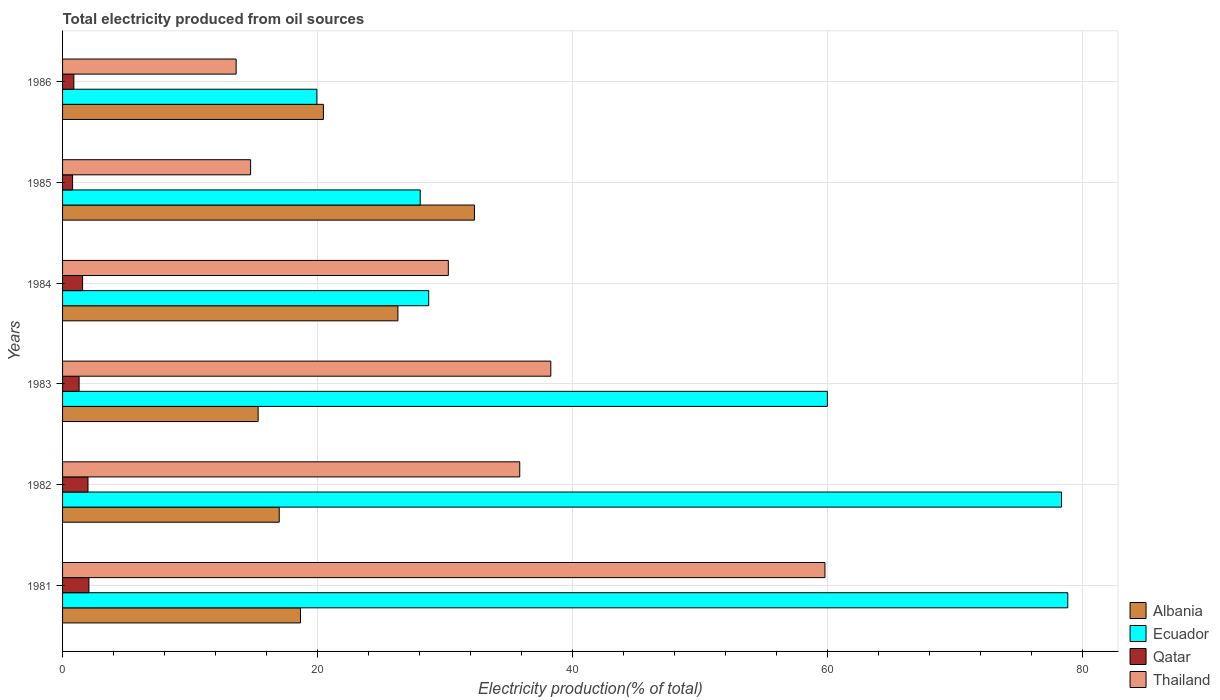How many different coloured bars are there?
Offer a terse response. 4. How many groups of bars are there?
Make the answer very short. 6. Are the number of bars per tick equal to the number of legend labels?
Your response must be concise. Yes. Are the number of bars on each tick of the Y-axis equal?
Provide a succinct answer. Yes. How many bars are there on the 6th tick from the bottom?
Offer a terse response. 4. In how many cases, is the number of bars for a given year not equal to the number of legend labels?
Give a very brief answer. 0. What is the total electricity produced in Albania in 1981?
Your answer should be very brief. 18.67. Across all years, what is the maximum total electricity produced in Ecuador?
Your answer should be very brief. 78.87. Across all years, what is the minimum total electricity produced in Thailand?
Your response must be concise. 13.62. What is the total total electricity produced in Thailand in the graph?
Ensure brevity in your answer.  192.63. What is the difference between the total electricity produced in Thailand in 1981 and that in 1984?
Provide a succinct answer. 29.55. What is the difference between the total electricity produced in Qatar in 1981 and the total electricity produced in Albania in 1984?
Make the answer very short. -24.24. What is the average total electricity produced in Thailand per year?
Ensure brevity in your answer.  32.1. In the year 1982, what is the difference between the total electricity produced in Thailand and total electricity produced in Qatar?
Your answer should be compact. 33.88. What is the ratio of the total electricity produced in Ecuador in 1981 to that in 1984?
Provide a short and direct response. 2.75. What is the difference between the highest and the second highest total electricity produced in Ecuador?
Make the answer very short. 0.49. What is the difference between the highest and the lowest total electricity produced in Ecuador?
Offer a very short reply. 58.91. Is it the case that in every year, the sum of the total electricity produced in Albania and total electricity produced in Ecuador is greater than the sum of total electricity produced in Qatar and total electricity produced in Thailand?
Give a very brief answer. Yes. What does the 2nd bar from the top in 1984 represents?
Provide a succinct answer. Qatar. What does the 3rd bar from the bottom in 1986 represents?
Your answer should be compact. Qatar. How many bars are there?
Keep it short and to the point. 24. Are all the bars in the graph horizontal?
Make the answer very short. Yes. What is the difference between two consecutive major ticks on the X-axis?
Keep it short and to the point. 20. Does the graph contain grids?
Keep it short and to the point. Yes. How many legend labels are there?
Offer a very short reply. 4. What is the title of the graph?
Keep it short and to the point. Total electricity produced from oil sources. Does "Algeria" appear as one of the legend labels in the graph?
Give a very brief answer. No. What is the Electricity production(% of total) in Albania in 1981?
Your answer should be very brief. 18.67. What is the Electricity production(% of total) of Ecuador in 1981?
Your answer should be very brief. 78.87. What is the Electricity production(% of total) of Qatar in 1981?
Provide a short and direct response. 2.07. What is the Electricity production(% of total) of Thailand in 1981?
Offer a terse response. 59.82. What is the Electricity production(% of total) of Albania in 1982?
Provide a succinct answer. 17. What is the Electricity production(% of total) in Ecuador in 1982?
Provide a succinct answer. 78.38. What is the Electricity production(% of total) in Qatar in 1982?
Keep it short and to the point. 1.99. What is the Electricity production(% of total) of Thailand in 1982?
Make the answer very short. 35.87. What is the Electricity production(% of total) of Albania in 1983?
Your answer should be compact. 15.34. What is the Electricity production(% of total) of Ecuador in 1983?
Provide a short and direct response. 60. What is the Electricity production(% of total) of Qatar in 1983?
Offer a very short reply. 1.3. What is the Electricity production(% of total) of Thailand in 1983?
Ensure brevity in your answer.  38.31. What is the Electricity production(% of total) of Albania in 1984?
Give a very brief answer. 26.31. What is the Electricity production(% of total) in Ecuador in 1984?
Keep it short and to the point. 28.73. What is the Electricity production(% of total) of Qatar in 1984?
Your answer should be compact. 1.57. What is the Electricity production(% of total) of Thailand in 1984?
Offer a terse response. 30.27. What is the Electricity production(% of total) of Albania in 1985?
Provide a succinct answer. 32.32. What is the Electricity production(% of total) of Ecuador in 1985?
Offer a very short reply. 28.06. What is the Electricity production(% of total) in Qatar in 1985?
Make the answer very short. 0.79. What is the Electricity production(% of total) in Thailand in 1985?
Your answer should be very brief. 14.75. What is the Electricity production(% of total) in Albania in 1986?
Offer a terse response. 20.47. What is the Electricity production(% of total) of Ecuador in 1986?
Your answer should be compact. 19.95. What is the Electricity production(% of total) in Qatar in 1986?
Offer a terse response. 0.89. What is the Electricity production(% of total) of Thailand in 1986?
Your response must be concise. 13.62. Across all years, what is the maximum Electricity production(% of total) in Albania?
Your response must be concise. 32.32. Across all years, what is the maximum Electricity production(% of total) in Ecuador?
Provide a short and direct response. 78.87. Across all years, what is the maximum Electricity production(% of total) in Qatar?
Your answer should be compact. 2.07. Across all years, what is the maximum Electricity production(% of total) of Thailand?
Your answer should be very brief. 59.82. Across all years, what is the minimum Electricity production(% of total) in Albania?
Ensure brevity in your answer.  15.34. Across all years, what is the minimum Electricity production(% of total) of Ecuador?
Give a very brief answer. 19.95. Across all years, what is the minimum Electricity production(% of total) of Qatar?
Provide a short and direct response. 0.79. Across all years, what is the minimum Electricity production(% of total) in Thailand?
Provide a succinct answer. 13.62. What is the total Electricity production(% of total) in Albania in the graph?
Offer a very short reply. 130.1. What is the total Electricity production(% of total) of Ecuador in the graph?
Provide a succinct answer. 293.99. What is the total Electricity production(% of total) in Qatar in the graph?
Your response must be concise. 8.6. What is the total Electricity production(% of total) in Thailand in the graph?
Provide a succinct answer. 192.63. What is the difference between the Electricity production(% of total) in Albania in 1981 and that in 1982?
Keep it short and to the point. 1.67. What is the difference between the Electricity production(% of total) of Ecuador in 1981 and that in 1982?
Make the answer very short. 0.49. What is the difference between the Electricity production(% of total) of Qatar in 1981 and that in 1982?
Ensure brevity in your answer.  0.07. What is the difference between the Electricity production(% of total) of Thailand in 1981 and that in 1982?
Provide a succinct answer. 23.95. What is the difference between the Electricity production(% of total) of Albania in 1981 and that in 1983?
Offer a terse response. 3.32. What is the difference between the Electricity production(% of total) of Ecuador in 1981 and that in 1983?
Ensure brevity in your answer.  18.86. What is the difference between the Electricity production(% of total) in Qatar in 1981 and that in 1983?
Keep it short and to the point. 0.77. What is the difference between the Electricity production(% of total) in Thailand in 1981 and that in 1983?
Provide a short and direct response. 21.51. What is the difference between the Electricity production(% of total) in Albania in 1981 and that in 1984?
Your answer should be compact. -7.64. What is the difference between the Electricity production(% of total) of Ecuador in 1981 and that in 1984?
Provide a succinct answer. 50.14. What is the difference between the Electricity production(% of total) of Qatar in 1981 and that in 1984?
Provide a short and direct response. 0.5. What is the difference between the Electricity production(% of total) of Thailand in 1981 and that in 1984?
Make the answer very short. 29.55. What is the difference between the Electricity production(% of total) in Albania in 1981 and that in 1985?
Provide a succinct answer. -13.65. What is the difference between the Electricity production(% of total) in Ecuador in 1981 and that in 1985?
Keep it short and to the point. 50.81. What is the difference between the Electricity production(% of total) in Qatar in 1981 and that in 1985?
Provide a short and direct response. 1.28. What is the difference between the Electricity production(% of total) in Thailand in 1981 and that in 1985?
Your answer should be very brief. 45.06. What is the difference between the Electricity production(% of total) of Albania in 1981 and that in 1986?
Provide a short and direct response. -1.8. What is the difference between the Electricity production(% of total) of Ecuador in 1981 and that in 1986?
Offer a very short reply. 58.91. What is the difference between the Electricity production(% of total) in Qatar in 1981 and that in 1986?
Your answer should be very brief. 1.18. What is the difference between the Electricity production(% of total) of Thailand in 1981 and that in 1986?
Provide a short and direct response. 46.2. What is the difference between the Electricity production(% of total) in Albania in 1982 and that in 1983?
Keep it short and to the point. 1.65. What is the difference between the Electricity production(% of total) of Ecuador in 1982 and that in 1983?
Your response must be concise. 18.37. What is the difference between the Electricity production(% of total) of Qatar in 1982 and that in 1983?
Ensure brevity in your answer.  0.7. What is the difference between the Electricity production(% of total) in Thailand in 1982 and that in 1983?
Make the answer very short. -2.44. What is the difference between the Electricity production(% of total) of Albania in 1982 and that in 1984?
Offer a very short reply. -9.31. What is the difference between the Electricity production(% of total) of Ecuador in 1982 and that in 1984?
Provide a succinct answer. 49.65. What is the difference between the Electricity production(% of total) in Qatar in 1982 and that in 1984?
Make the answer very short. 0.42. What is the difference between the Electricity production(% of total) of Thailand in 1982 and that in 1984?
Ensure brevity in your answer.  5.6. What is the difference between the Electricity production(% of total) of Albania in 1982 and that in 1985?
Make the answer very short. -15.32. What is the difference between the Electricity production(% of total) of Ecuador in 1982 and that in 1985?
Make the answer very short. 50.32. What is the difference between the Electricity production(% of total) of Qatar in 1982 and that in 1985?
Provide a short and direct response. 1.21. What is the difference between the Electricity production(% of total) in Thailand in 1982 and that in 1985?
Offer a very short reply. 21.12. What is the difference between the Electricity production(% of total) of Albania in 1982 and that in 1986?
Offer a terse response. -3.47. What is the difference between the Electricity production(% of total) of Ecuador in 1982 and that in 1986?
Provide a short and direct response. 58.42. What is the difference between the Electricity production(% of total) of Qatar in 1982 and that in 1986?
Provide a succinct answer. 1.11. What is the difference between the Electricity production(% of total) of Thailand in 1982 and that in 1986?
Keep it short and to the point. 22.25. What is the difference between the Electricity production(% of total) of Albania in 1983 and that in 1984?
Offer a very short reply. -10.97. What is the difference between the Electricity production(% of total) in Ecuador in 1983 and that in 1984?
Ensure brevity in your answer.  31.28. What is the difference between the Electricity production(% of total) of Qatar in 1983 and that in 1984?
Ensure brevity in your answer.  -0.27. What is the difference between the Electricity production(% of total) of Thailand in 1983 and that in 1984?
Make the answer very short. 8.04. What is the difference between the Electricity production(% of total) of Albania in 1983 and that in 1985?
Ensure brevity in your answer.  -16.97. What is the difference between the Electricity production(% of total) in Ecuador in 1983 and that in 1985?
Keep it short and to the point. 31.94. What is the difference between the Electricity production(% of total) of Qatar in 1983 and that in 1985?
Your response must be concise. 0.51. What is the difference between the Electricity production(% of total) of Thailand in 1983 and that in 1985?
Offer a very short reply. 23.55. What is the difference between the Electricity production(% of total) of Albania in 1983 and that in 1986?
Offer a terse response. -5.12. What is the difference between the Electricity production(% of total) of Ecuador in 1983 and that in 1986?
Make the answer very short. 40.05. What is the difference between the Electricity production(% of total) in Qatar in 1983 and that in 1986?
Make the answer very short. 0.41. What is the difference between the Electricity production(% of total) in Thailand in 1983 and that in 1986?
Provide a short and direct response. 24.69. What is the difference between the Electricity production(% of total) in Albania in 1984 and that in 1985?
Your answer should be compact. -6. What is the difference between the Electricity production(% of total) in Ecuador in 1984 and that in 1985?
Your answer should be very brief. 0.67. What is the difference between the Electricity production(% of total) in Qatar in 1984 and that in 1985?
Offer a very short reply. 0.79. What is the difference between the Electricity production(% of total) of Thailand in 1984 and that in 1985?
Your answer should be very brief. 15.51. What is the difference between the Electricity production(% of total) in Albania in 1984 and that in 1986?
Ensure brevity in your answer.  5.85. What is the difference between the Electricity production(% of total) of Ecuador in 1984 and that in 1986?
Provide a succinct answer. 8.77. What is the difference between the Electricity production(% of total) of Qatar in 1984 and that in 1986?
Your answer should be very brief. 0.69. What is the difference between the Electricity production(% of total) of Thailand in 1984 and that in 1986?
Keep it short and to the point. 16.65. What is the difference between the Electricity production(% of total) in Albania in 1985 and that in 1986?
Your response must be concise. 11.85. What is the difference between the Electricity production(% of total) in Ecuador in 1985 and that in 1986?
Provide a succinct answer. 8.11. What is the difference between the Electricity production(% of total) in Qatar in 1985 and that in 1986?
Give a very brief answer. -0.1. What is the difference between the Electricity production(% of total) in Thailand in 1985 and that in 1986?
Offer a terse response. 1.13. What is the difference between the Electricity production(% of total) in Albania in 1981 and the Electricity production(% of total) in Ecuador in 1982?
Provide a short and direct response. -59.71. What is the difference between the Electricity production(% of total) in Albania in 1981 and the Electricity production(% of total) in Qatar in 1982?
Your response must be concise. 16.67. What is the difference between the Electricity production(% of total) of Albania in 1981 and the Electricity production(% of total) of Thailand in 1982?
Keep it short and to the point. -17.2. What is the difference between the Electricity production(% of total) of Ecuador in 1981 and the Electricity production(% of total) of Qatar in 1982?
Keep it short and to the point. 76.87. What is the difference between the Electricity production(% of total) of Ecuador in 1981 and the Electricity production(% of total) of Thailand in 1982?
Give a very brief answer. 43. What is the difference between the Electricity production(% of total) in Qatar in 1981 and the Electricity production(% of total) in Thailand in 1982?
Your response must be concise. -33.8. What is the difference between the Electricity production(% of total) of Albania in 1981 and the Electricity production(% of total) of Ecuador in 1983?
Offer a very short reply. -41.34. What is the difference between the Electricity production(% of total) of Albania in 1981 and the Electricity production(% of total) of Qatar in 1983?
Offer a terse response. 17.37. What is the difference between the Electricity production(% of total) in Albania in 1981 and the Electricity production(% of total) in Thailand in 1983?
Provide a succinct answer. -19.64. What is the difference between the Electricity production(% of total) of Ecuador in 1981 and the Electricity production(% of total) of Qatar in 1983?
Give a very brief answer. 77.57. What is the difference between the Electricity production(% of total) of Ecuador in 1981 and the Electricity production(% of total) of Thailand in 1983?
Provide a short and direct response. 40.56. What is the difference between the Electricity production(% of total) in Qatar in 1981 and the Electricity production(% of total) in Thailand in 1983?
Your answer should be compact. -36.24. What is the difference between the Electricity production(% of total) of Albania in 1981 and the Electricity production(% of total) of Ecuador in 1984?
Offer a very short reply. -10.06. What is the difference between the Electricity production(% of total) in Albania in 1981 and the Electricity production(% of total) in Qatar in 1984?
Ensure brevity in your answer.  17.09. What is the difference between the Electricity production(% of total) in Albania in 1981 and the Electricity production(% of total) in Thailand in 1984?
Make the answer very short. -11.6. What is the difference between the Electricity production(% of total) of Ecuador in 1981 and the Electricity production(% of total) of Qatar in 1984?
Your response must be concise. 77.29. What is the difference between the Electricity production(% of total) in Ecuador in 1981 and the Electricity production(% of total) in Thailand in 1984?
Provide a succinct answer. 48.6. What is the difference between the Electricity production(% of total) in Qatar in 1981 and the Electricity production(% of total) in Thailand in 1984?
Your response must be concise. -28.2. What is the difference between the Electricity production(% of total) in Albania in 1981 and the Electricity production(% of total) in Ecuador in 1985?
Offer a terse response. -9.39. What is the difference between the Electricity production(% of total) of Albania in 1981 and the Electricity production(% of total) of Qatar in 1985?
Offer a very short reply. 17.88. What is the difference between the Electricity production(% of total) of Albania in 1981 and the Electricity production(% of total) of Thailand in 1985?
Ensure brevity in your answer.  3.91. What is the difference between the Electricity production(% of total) in Ecuador in 1981 and the Electricity production(% of total) in Qatar in 1985?
Your answer should be compact. 78.08. What is the difference between the Electricity production(% of total) in Ecuador in 1981 and the Electricity production(% of total) in Thailand in 1985?
Make the answer very short. 64.11. What is the difference between the Electricity production(% of total) in Qatar in 1981 and the Electricity production(% of total) in Thailand in 1985?
Keep it short and to the point. -12.69. What is the difference between the Electricity production(% of total) in Albania in 1981 and the Electricity production(% of total) in Ecuador in 1986?
Offer a terse response. -1.29. What is the difference between the Electricity production(% of total) in Albania in 1981 and the Electricity production(% of total) in Qatar in 1986?
Your response must be concise. 17.78. What is the difference between the Electricity production(% of total) of Albania in 1981 and the Electricity production(% of total) of Thailand in 1986?
Make the answer very short. 5.05. What is the difference between the Electricity production(% of total) in Ecuador in 1981 and the Electricity production(% of total) in Qatar in 1986?
Offer a terse response. 77.98. What is the difference between the Electricity production(% of total) in Ecuador in 1981 and the Electricity production(% of total) in Thailand in 1986?
Make the answer very short. 65.25. What is the difference between the Electricity production(% of total) of Qatar in 1981 and the Electricity production(% of total) of Thailand in 1986?
Your response must be concise. -11.55. What is the difference between the Electricity production(% of total) of Albania in 1982 and the Electricity production(% of total) of Ecuador in 1983?
Offer a very short reply. -43.01. What is the difference between the Electricity production(% of total) of Albania in 1982 and the Electricity production(% of total) of Qatar in 1983?
Your answer should be very brief. 15.7. What is the difference between the Electricity production(% of total) of Albania in 1982 and the Electricity production(% of total) of Thailand in 1983?
Offer a terse response. -21.31. What is the difference between the Electricity production(% of total) in Ecuador in 1982 and the Electricity production(% of total) in Qatar in 1983?
Provide a succinct answer. 77.08. What is the difference between the Electricity production(% of total) in Ecuador in 1982 and the Electricity production(% of total) in Thailand in 1983?
Your answer should be very brief. 40.07. What is the difference between the Electricity production(% of total) of Qatar in 1982 and the Electricity production(% of total) of Thailand in 1983?
Your response must be concise. -36.31. What is the difference between the Electricity production(% of total) in Albania in 1982 and the Electricity production(% of total) in Ecuador in 1984?
Make the answer very short. -11.73. What is the difference between the Electricity production(% of total) in Albania in 1982 and the Electricity production(% of total) in Qatar in 1984?
Your response must be concise. 15.43. What is the difference between the Electricity production(% of total) in Albania in 1982 and the Electricity production(% of total) in Thailand in 1984?
Offer a terse response. -13.27. What is the difference between the Electricity production(% of total) of Ecuador in 1982 and the Electricity production(% of total) of Qatar in 1984?
Your answer should be very brief. 76.8. What is the difference between the Electricity production(% of total) of Ecuador in 1982 and the Electricity production(% of total) of Thailand in 1984?
Provide a succinct answer. 48.11. What is the difference between the Electricity production(% of total) of Qatar in 1982 and the Electricity production(% of total) of Thailand in 1984?
Your response must be concise. -28.27. What is the difference between the Electricity production(% of total) in Albania in 1982 and the Electricity production(% of total) in Ecuador in 1985?
Your answer should be compact. -11.06. What is the difference between the Electricity production(% of total) in Albania in 1982 and the Electricity production(% of total) in Qatar in 1985?
Make the answer very short. 16.21. What is the difference between the Electricity production(% of total) in Albania in 1982 and the Electricity production(% of total) in Thailand in 1985?
Offer a very short reply. 2.25. What is the difference between the Electricity production(% of total) in Ecuador in 1982 and the Electricity production(% of total) in Qatar in 1985?
Your response must be concise. 77.59. What is the difference between the Electricity production(% of total) of Ecuador in 1982 and the Electricity production(% of total) of Thailand in 1985?
Keep it short and to the point. 63.62. What is the difference between the Electricity production(% of total) in Qatar in 1982 and the Electricity production(% of total) in Thailand in 1985?
Make the answer very short. -12.76. What is the difference between the Electricity production(% of total) of Albania in 1982 and the Electricity production(% of total) of Ecuador in 1986?
Give a very brief answer. -2.95. What is the difference between the Electricity production(% of total) of Albania in 1982 and the Electricity production(% of total) of Qatar in 1986?
Ensure brevity in your answer.  16.11. What is the difference between the Electricity production(% of total) of Albania in 1982 and the Electricity production(% of total) of Thailand in 1986?
Give a very brief answer. 3.38. What is the difference between the Electricity production(% of total) in Ecuador in 1982 and the Electricity production(% of total) in Qatar in 1986?
Your response must be concise. 77.49. What is the difference between the Electricity production(% of total) in Ecuador in 1982 and the Electricity production(% of total) in Thailand in 1986?
Your answer should be very brief. 64.76. What is the difference between the Electricity production(% of total) in Qatar in 1982 and the Electricity production(% of total) in Thailand in 1986?
Your response must be concise. -11.62. What is the difference between the Electricity production(% of total) of Albania in 1983 and the Electricity production(% of total) of Ecuador in 1984?
Give a very brief answer. -13.38. What is the difference between the Electricity production(% of total) of Albania in 1983 and the Electricity production(% of total) of Qatar in 1984?
Make the answer very short. 13.77. What is the difference between the Electricity production(% of total) of Albania in 1983 and the Electricity production(% of total) of Thailand in 1984?
Provide a short and direct response. -14.92. What is the difference between the Electricity production(% of total) in Ecuador in 1983 and the Electricity production(% of total) in Qatar in 1984?
Make the answer very short. 58.43. What is the difference between the Electricity production(% of total) of Ecuador in 1983 and the Electricity production(% of total) of Thailand in 1984?
Give a very brief answer. 29.74. What is the difference between the Electricity production(% of total) of Qatar in 1983 and the Electricity production(% of total) of Thailand in 1984?
Keep it short and to the point. -28.97. What is the difference between the Electricity production(% of total) in Albania in 1983 and the Electricity production(% of total) in Ecuador in 1985?
Offer a terse response. -12.72. What is the difference between the Electricity production(% of total) in Albania in 1983 and the Electricity production(% of total) in Qatar in 1985?
Ensure brevity in your answer.  14.56. What is the difference between the Electricity production(% of total) in Albania in 1983 and the Electricity production(% of total) in Thailand in 1985?
Provide a succinct answer. 0.59. What is the difference between the Electricity production(% of total) of Ecuador in 1983 and the Electricity production(% of total) of Qatar in 1985?
Your response must be concise. 59.22. What is the difference between the Electricity production(% of total) of Ecuador in 1983 and the Electricity production(% of total) of Thailand in 1985?
Offer a very short reply. 45.25. What is the difference between the Electricity production(% of total) of Qatar in 1983 and the Electricity production(% of total) of Thailand in 1985?
Provide a short and direct response. -13.45. What is the difference between the Electricity production(% of total) in Albania in 1983 and the Electricity production(% of total) in Ecuador in 1986?
Give a very brief answer. -4.61. What is the difference between the Electricity production(% of total) of Albania in 1983 and the Electricity production(% of total) of Qatar in 1986?
Keep it short and to the point. 14.46. What is the difference between the Electricity production(% of total) in Albania in 1983 and the Electricity production(% of total) in Thailand in 1986?
Offer a very short reply. 1.73. What is the difference between the Electricity production(% of total) in Ecuador in 1983 and the Electricity production(% of total) in Qatar in 1986?
Ensure brevity in your answer.  59.12. What is the difference between the Electricity production(% of total) of Ecuador in 1983 and the Electricity production(% of total) of Thailand in 1986?
Make the answer very short. 46.39. What is the difference between the Electricity production(% of total) in Qatar in 1983 and the Electricity production(% of total) in Thailand in 1986?
Your response must be concise. -12.32. What is the difference between the Electricity production(% of total) in Albania in 1984 and the Electricity production(% of total) in Ecuador in 1985?
Make the answer very short. -1.75. What is the difference between the Electricity production(% of total) of Albania in 1984 and the Electricity production(% of total) of Qatar in 1985?
Your answer should be compact. 25.53. What is the difference between the Electricity production(% of total) of Albania in 1984 and the Electricity production(% of total) of Thailand in 1985?
Give a very brief answer. 11.56. What is the difference between the Electricity production(% of total) in Ecuador in 1984 and the Electricity production(% of total) in Qatar in 1985?
Make the answer very short. 27.94. What is the difference between the Electricity production(% of total) in Ecuador in 1984 and the Electricity production(% of total) in Thailand in 1985?
Provide a short and direct response. 13.97. What is the difference between the Electricity production(% of total) in Qatar in 1984 and the Electricity production(% of total) in Thailand in 1985?
Provide a succinct answer. -13.18. What is the difference between the Electricity production(% of total) of Albania in 1984 and the Electricity production(% of total) of Ecuador in 1986?
Provide a succinct answer. 6.36. What is the difference between the Electricity production(% of total) of Albania in 1984 and the Electricity production(% of total) of Qatar in 1986?
Your answer should be very brief. 25.43. What is the difference between the Electricity production(% of total) of Albania in 1984 and the Electricity production(% of total) of Thailand in 1986?
Your response must be concise. 12.69. What is the difference between the Electricity production(% of total) in Ecuador in 1984 and the Electricity production(% of total) in Qatar in 1986?
Make the answer very short. 27.84. What is the difference between the Electricity production(% of total) of Ecuador in 1984 and the Electricity production(% of total) of Thailand in 1986?
Your answer should be compact. 15.11. What is the difference between the Electricity production(% of total) of Qatar in 1984 and the Electricity production(% of total) of Thailand in 1986?
Provide a short and direct response. -12.05. What is the difference between the Electricity production(% of total) of Albania in 1985 and the Electricity production(% of total) of Ecuador in 1986?
Offer a terse response. 12.36. What is the difference between the Electricity production(% of total) in Albania in 1985 and the Electricity production(% of total) in Qatar in 1986?
Offer a terse response. 31.43. What is the difference between the Electricity production(% of total) in Albania in 1985 and the Electricity production(% of total) in Thailand in 1986?
Provide a short and direct response. 18.7. What is the difference between the Electricity production(% of total) of Ecuador in 1985 and the Electricity production(% of total) of Qatar in 1986?
Your answer should be compact. 27.17. What is the difference between the Electricity production(% of total) of Ecuador in 1985 and the Electricity production(% of total) of Thailand in 1986?
Your answer should be very brief. 14.44. What is the difference between the Electricity production(% of total) in Qatar in 1985 and the Electricity production(% of total) in Thailand in 1986?
Offer a very short reply. -12.83. What is the average Electricity production(% of total) in Albania per year?
Make the answer very short. 21.68. What is the average Electricity production(% of total) in Ecuador per year?
Provide a short and direct response. 49. What is the average Electricity production(% of total) in Qatar per year?
Your response must be concise. 1.43. What is the average Electricity production(% of total) in Thailand per year?
Your answer should be compact. 32.1. In the year 1981, what is the difference between the Electricity production(% of total) in Albania and Electricity production(% of total) in Ecuador?
Ensure brevity in your answer.  -60.2. In the year 1981, what is the difference between the Electricity production(% of total) in Albania and Electricity production(% of total) in Qatar?
Ensure brevity in your answer.  16.6. In the year 1981, what is the difference between the Electricity production(% of total) in Albania and Electricity production(% of total) in Thailand?
Offer a very short reply. -41.15. In the year 1981, what is the difference between the Electricity production(% of total) of Ecuador and Electricity production(% of total) of Qatar?
Your answer should be compact. 76.8. In the year 1981, what is the difference between the Electricity production(% of total) in Ecuador and Electricity production(% of total) in Thailand?
Keep it short and to the point. 19.05. In the year 1981, what is the difference between the Electricity production(% of total) of Qatar and Electricity production(% of total) of Thailand?
Keep it short and to the point. -57.75. In the year 1982, what is the difference between the Electricity production(% of total) in Albania and Electricity production(% of total) in Ecuador?
Your response must be concise. -61.38. In the year 1982, what is the difference between the Electricity production(% of total) in Albania and Electricity production(% of total) in Qatar?
Provide a succinct answer. 15. In the year 1982, what is the difference between the Electricity production(% of total) in Albania and Electricity production(% of total) in Thailand?
Offer a terse response. -18.87. In the year 1982, what is the difference between the Electricity production(% of total) of Ecuador and Electricity production(% of total) of Qatar?
Keep it short and to the point. 76.38. In the year 1982, what is the difference between the Electricity production(% of total) in Ecuador and Electricity production(% of total) in Thailand?
Make the answer very short. 42.51. In the year 1982, what is the difference between the Electricity production(% of total) of Qatar and Electricity production(% of total) of Thailand?
Keep it short and to the point. -33.88. In the year 1983, what is the difference between the Electricity production(% of total) in Albania and Electricity production(% of total) in Ecuador?
Ensure brevity in your answer.  -44.66. In the year 1983, what is the difference between the Electricity production(% of total) of Albania and Electricity production(% of total) of Qatar?
Make the answer very short. 14.05. In the year 1983, what is the difference between the Electricity production(% of total) of Albania and Electricity production(% of total) of Thailand?
Keep it short and to the point. -22.96. In the year 1983, what is the difference between the Electricity production(% of total) of Ecuador and Electricity production(% of total) of Qatar?
Make the answer very short. 58.71. In the year 1983, what is the difference between the Electricity production(% of total) in Ecuador and Electricity production(% of total) in Thailand?
Your response must be concise. 21.7. In the year 1983, what is the difference between the Electricity production(% of total) in Qatar and Electricity production(% of total) in Thailand?
Give a very brief answer. -37.01. In the year 1984, what is the difference between the Electricity production(% of total) of Albania and Electricity production(% of total) of Ecuador?
Your answer should be very brief. -2.41. In the year 1984, what is the difference between the Electricity production(% of total) in Albania and Electricity production(% of total) in Qatar?
Give a very brief answer. 24.74. In the year 1984, what is the difference between the Electricity production(% of total) of Albania and Electricity production(% of total) of Thailand?
Offer a terse response. -3.95. In the year 1984, what is the difference between the Electricity production(% of total) of Ecuador and Electricity production(% of total) of Qatar?
Make the answer very short. 27.15. In the year 1984, what is the difference between the Electricity production(% of total) in Ecuador and Electricity production(% of total) in Thailand?
Provide a succinct answer. -1.54. In the year 1984, what is the difference between the Electricity production(% of total) of Qatar and Electricity production(% of total) of Thailand?
Keep it short and to the point. -28.69. In the year 1985, what is the difference between the Electricity production(% of total) in Albania and Electricity production(% of total) in Ecuador?
Ensure brevity in your answer.  4.26. In the year 1985, what is the difference between the Electricity production(% of total) of Albania and Electricity production(% of total) of Qatar?
Offer a very short reply. 31.53. In the year 1985, what is the difference between the Electricity production(% of total) of Albania and Electricity production(% of total) of Thailand?
Provide a succinct answer. 17.56. In the year 1985, what is the difference between the Electricity production(% of total) of Ecuador and Electricity production(% of total) of Qatar?
Give a very brief answer. 27.28. In the year 1985, what is the difference between the Electricity production(% of total) in Ecuador and Electricity production(% of total) in Thailand?
Provide a succinct answer. 13.31. In the year 1985, what is the difference between the Electricity production(% of total) of Qatar and Electricity production(% of total) of Thailand?
Offer a terse response. -13.97. In the year 1986, what is the difference between the Electricity production(% of total) in Albania and Electricity production(% of total) in Ecuador?
Give a very brief answer. 0.51. In the year 1986, what is the difference between the Electricity production(% of total) of Albania and Electricity production(% of total) of Qatar?
Make the answer very short. 19.58. In the year 1986, what is the difference between the Electricity production(% of total) in Albania and Electricity production(% of total) in Thailand?
Provide a succinct answer. 6.85. In the year 1986, what is the difference between the Electricity production(% of total) in Ecuador and Electricity production(% of total) in Qatar?
Offer a terse response. 19.07. In the year 1986, what is the difference between the Electricity production(% of total) in Ecuador and Electricity production(% of total) in Thailand?
Your answer should be very brief. 6.33. In the year 1986, what is the difference between the Electricity production(% of total) of Qatar and Electricity production(% of total) of Thailand?
Keep it short and to the point. -12.73. What is the ratio of the Electricity production(% of total) of Albania in 1981 to that in 1982?
Provide a succinct answer. 1.1. What is the ratio of the Electricity production(% of total) in Qatar in 1981 to that in 1982?
Provide a short and direct response. 1.04. What is the ratio of the Electricity production(% of total) in Thailand in 1981 to that in 1982?
Make the answer very short. 1.67. What is the ratio of the Electricity production(% of total) of Albania in 1981 to that in 1983?
Your answer should be very brief. 1.22. What is the ratio of the Electricity production(% of total) of Ecuador in 1981 to that in 1983?
Keep it short and to the point. 1.31. What is the ratio of the Electricity production(% of total) of Qatar in 1981 to that in 1983?
Offer a terse response. 1.59. What is the ratio of the Electricity production(% of total) of Thailand in 1981 to that in 1983?
Give a very brief answer. 1.56. What is the ratio of the Electricity production(% of total) in Albania in 1981 to that in 1984?
Provide a short and direct response. 0.71. What is the ratio of the Electricity production(% of total) of Ecuador in 1981 to that in 1984?
Give a very brief answer. 2.75. What is the ratio of the Electricity production(% of total) of Qatar in 1981 to that in 1984?
Offer a very short reply. 1.32. What is the ratio of the Electricity production(% of total) in Thailand in 1981 to that in 1984?
Make the answer very short. 1.98. What is the ratio of the Electricity production(% of total) of Albania in 1981 to that in 1985?
Provide a succinct answer. 0.58. What is the ratio of the Electricity production(% of total) in Ecuador in 1981 to that in 1985?
Give a very brief answer. 2.81. What is the ratio of the Electricity production(% of total) of Qatar in 1981 to that in 1985?
Provide a short and direct response. 2.63. What is the ratio of the Electricity production(% of total) of Thailand in 1981 to that in 1985?
Offer a terse response. 4.05. What is the ratio of the Electricity production(% of total) in Albania in 1981 to that in 1986?
Your answer should be compact. 0.91. What is the ratio of the Electricity production(% of total) of Ecuador in 1981 to that in 1986?
Offer a very short reply. 3.95. What is the ratio of the Electricity production(% of total) in Qatar in 1981 to that in 1986?
Provide a succinct answer. 2.33. What is the ratio of the Electricity production(% of total) of Thailand in 1981 to that in 1986?
Provide a short and direct response. 4.39. What is the ratio of the Electricity production(% of total) of Albania in 1982 to that in 1983?
Offer a terse response. 1.11. What is the ratio of the Electricity production(% of total) of Ecuador in 1982 to that in 1983?
Your answer should be very brief. 1.31. What is the ratio of the Electricity production(% of total) of Qatar in 1982 to that in 1983?
Provide a succinct answer. 1.54. What is the ratio of the Electricity production(% of total) of Thailand in 1982 to that in 1983?
Offer a terse response. 0.94. What is the ratio of the Electricity production(% of total) of Albania in 1982 to that in 1984?
Give a very brief answer. 0.65. What is the ratio of the Electricity production(% of total) of Ecuador in 1982 to that in 1984?
Offer a very short reply. 2.73. What is the ratio of the Electricity production(% of total) in Qatar in 1982 to that in 1984?
Offer a very short reply. 1.27. What is the ratio of the Electricity production(% of total) in Thailand in 1982 to that in 1984?
Ensure brevity in your answer.  1.19. What is the ratio of the Electricity production(% of total) in Albania in 1982 to that in 1985?
Provide a succinct answer. 0.53. What is the ratio of the Electricity production(% of total) in Ecuador in 1982 to that in 1985?
Your answer should be very brief. 2.79. What is the ratio of the Electricity production(% of total) in Qatar in 1982 to that in 1985?
Your answer should be very brief. 2.54. What is the ratio of the Electricity production(% of total) in Thailand in 1982 to that in 1985?
Your answer should be compact. 2.43. What is the ratio of the Electricity production(% of total) in Albania in 1982 to that in 1986?
Your answer should be very brief. 0.83. What is the ratio of the Electricity production(% of total) of Ecuador in 1982 to that in 1986?
Make the answer very short. 3.93. What is the ratio of the Electricity production(% of total) in Qatar in 1982 to that in 1986?
Make the answer very short. 2.25. What is the ratio of the Electricity production(% of total) of Thailand in 1982 to that in 1986?
Ensure brevity in your answer.  2.63. What is the ratio of the Electricity production(% of total) of Albania in 1983 to that in 1984?
Your answer should be very brief. 0.58. What is the ratio of the Electricity production(% of total) of Ecuador in 1983 to that in 1984?
Offer a terse response. 2.09. What is the ratio of the Electricity production(% of total) in Qatar in 1983 to that in 1984?
Your answer should be compact. 0.83. What is the ratio of the Electricity production(% of total) in Thailand in 1983 to that in 1984?
Ensure brevity in your answer.  1.27. What is the ratio of the Electricity production(% of total) in Albania in 1983 to that in 1985?
Provide a succinct answer. 0.47. What is the ratio of the Electricity production(% of total) of Ecuador in 1983 to that in 1985?
Give a very brief answer. 2.14. What is the ratio of the Electricity production(% of total) of Qatar in 1983 to that in 1985?
Your response must be concise. 1.65. What is the ratio of the Electricity production(% of total) of Thailand in 1983 to that in 1985?
Offer a terse response. 2.6. What is the ratio of the Electricity production(% of total) of Albania in 1983 to that in 1986?
Your answer should be compact. 0.75. What is the ratio of the Electricity production(% of total) of Ecuador in 1983 to that in 1986?
Keep it short and to the point. 3.01. What is the ratio of the Electricity production(% of total) of Qatar in 1983 to that in 1986?
Give a very brief answer. 1.46. What is the ratio of the Electricity production(% of total) in Thailand in 1983 to that in 1986?
Make the answer very short. 2.81. What is the ratio of the Electricity production(% of total) of Albania in 1984 to that in 1985?
Offer a very short reply. 0.81. What is the ratio of the Electricity production(% of total) in Ecuador in 1984 to that in 1985?
Your answer should be compact. 1.02. What is the ratio of the Electricity production(% of total) in Qatar in 1984 to that in 1985?
Provide a short and direct response. 2. What is the ratio of the Electricity production(% of total) in Thailand in 1984 to that in 1985?
Make the answer very short. 2.05. What is the ratio of the Electricity production(% of total) in Albania in 1984 to that in 1986?
Make the answer very short. 1.29. What is the ratio of the Electricity production(% of total) in Ecuador in 1984 to that in 1986?
Offer a terse response. 1.44. What is the ratio of the Electricity production(% of total) in Qatar in 1984 to that in 1986?
Offer a terse response. 1.77. What is the ratio of the Electricity production(% of total) of Thailand in 1984 to that in 1986?
Make the answer very short. 2.22. What is the ratio of the Electricity production(% of total) of Albania in 1985 to that in 1986?
Offer a terse response. 1.58. What is the ratio of the Electricity production(% of total) of Ecuador in 1985 to that in 1986?
Your answer should be compact. 1.41. What is the ratio of the Electricity production(% of total) of Qatar in 1985 to that in 1986?
Your answer should be very brief. 0.89. What is the ratio of the Electricity production(% of total) of Thailand in 1985 to that in 1986?
Give a very brief answer. 1.08. What is the difference between the highest and the second highest Electricity production(% of total) in Albania?
Make the answer very short. 6. What is the difference between the highest and the second highest Electricity production(% of total) of Ecuador?
Give a very brief answer. 0.49. What is the difference between the highest and the second highest Electricity production(% of total) in Qatar?
Provide a short and direct response. 0.07. What is the difference between the highest and the second highest Electricity production(% of total) of Thailand?
Ensure brevity in your answer.  21.51. What is the difference between the highest and the lowest Electricity production(% of total) of Albania?
Make the answer very short. 16.97. What is the difference between the highest and the lowest Electricity production(% of total) of Ecuador?
Keep it short and to the point. 58.91. What is the difference between the highest and the lowest Electricity production(% of total) in Qatar?
Keep it short and to the point. 1.28. What is the difference between the highest and the lowest Electricity production(% of total) of Thailand?
Provide a succinct answer. 46.2. 